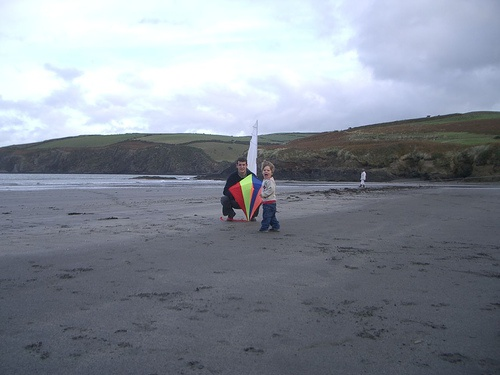Describe the objects in this image and their specific colors. I can see people in lavender, black, brown, navy, and gray tones, people in lavender, navy, gray, darkgray, and black tones, kite in lavender, brown, olive, and navy tones, and people in lavender, darkgray, gray, and black tones in this image. 